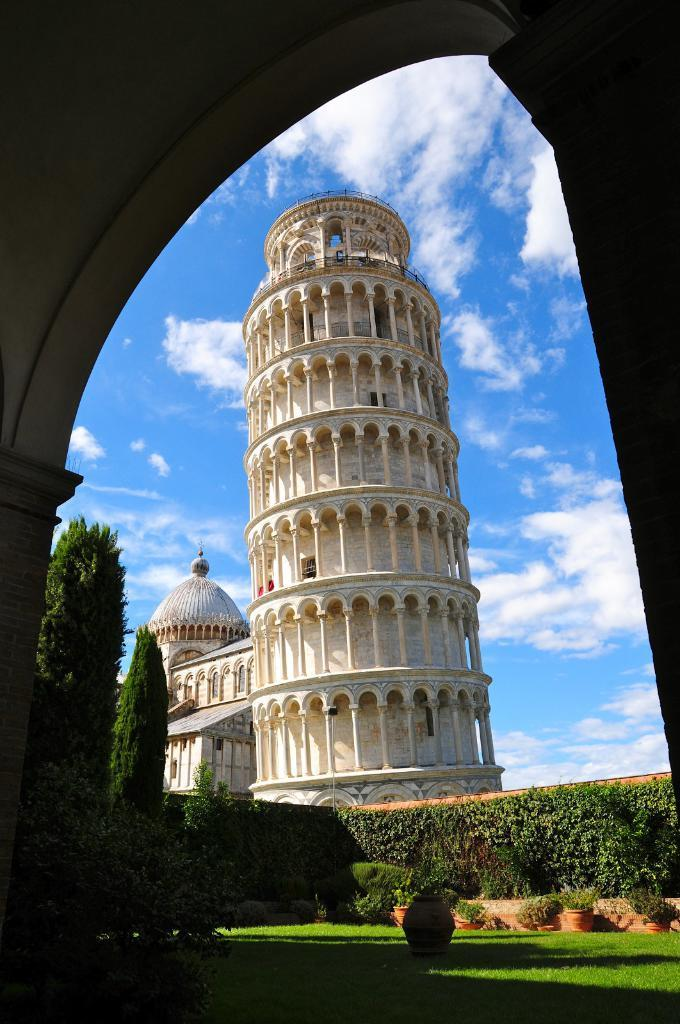What is the weather like in the image? The sky is cloudy in the image. What type of vegetation can be seen in the image? There is grass, plants, and trees in the image. What type of structure is present in the image? There is a castle in the image. How does the castle suggest an attack in the image? The castle does not suggest an attack in the image; it is simply a structure present in the scene. 